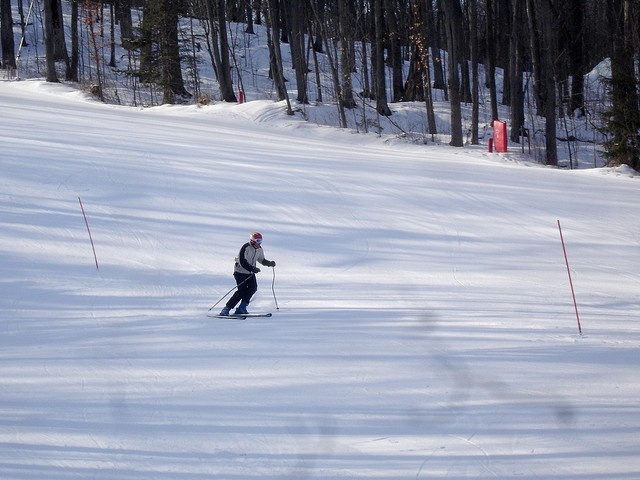Describe the objects in this image and their specific colors. I can see people in black, gray, and navy tones and skis in black, gray, darkgray, and navy tones in this image. 